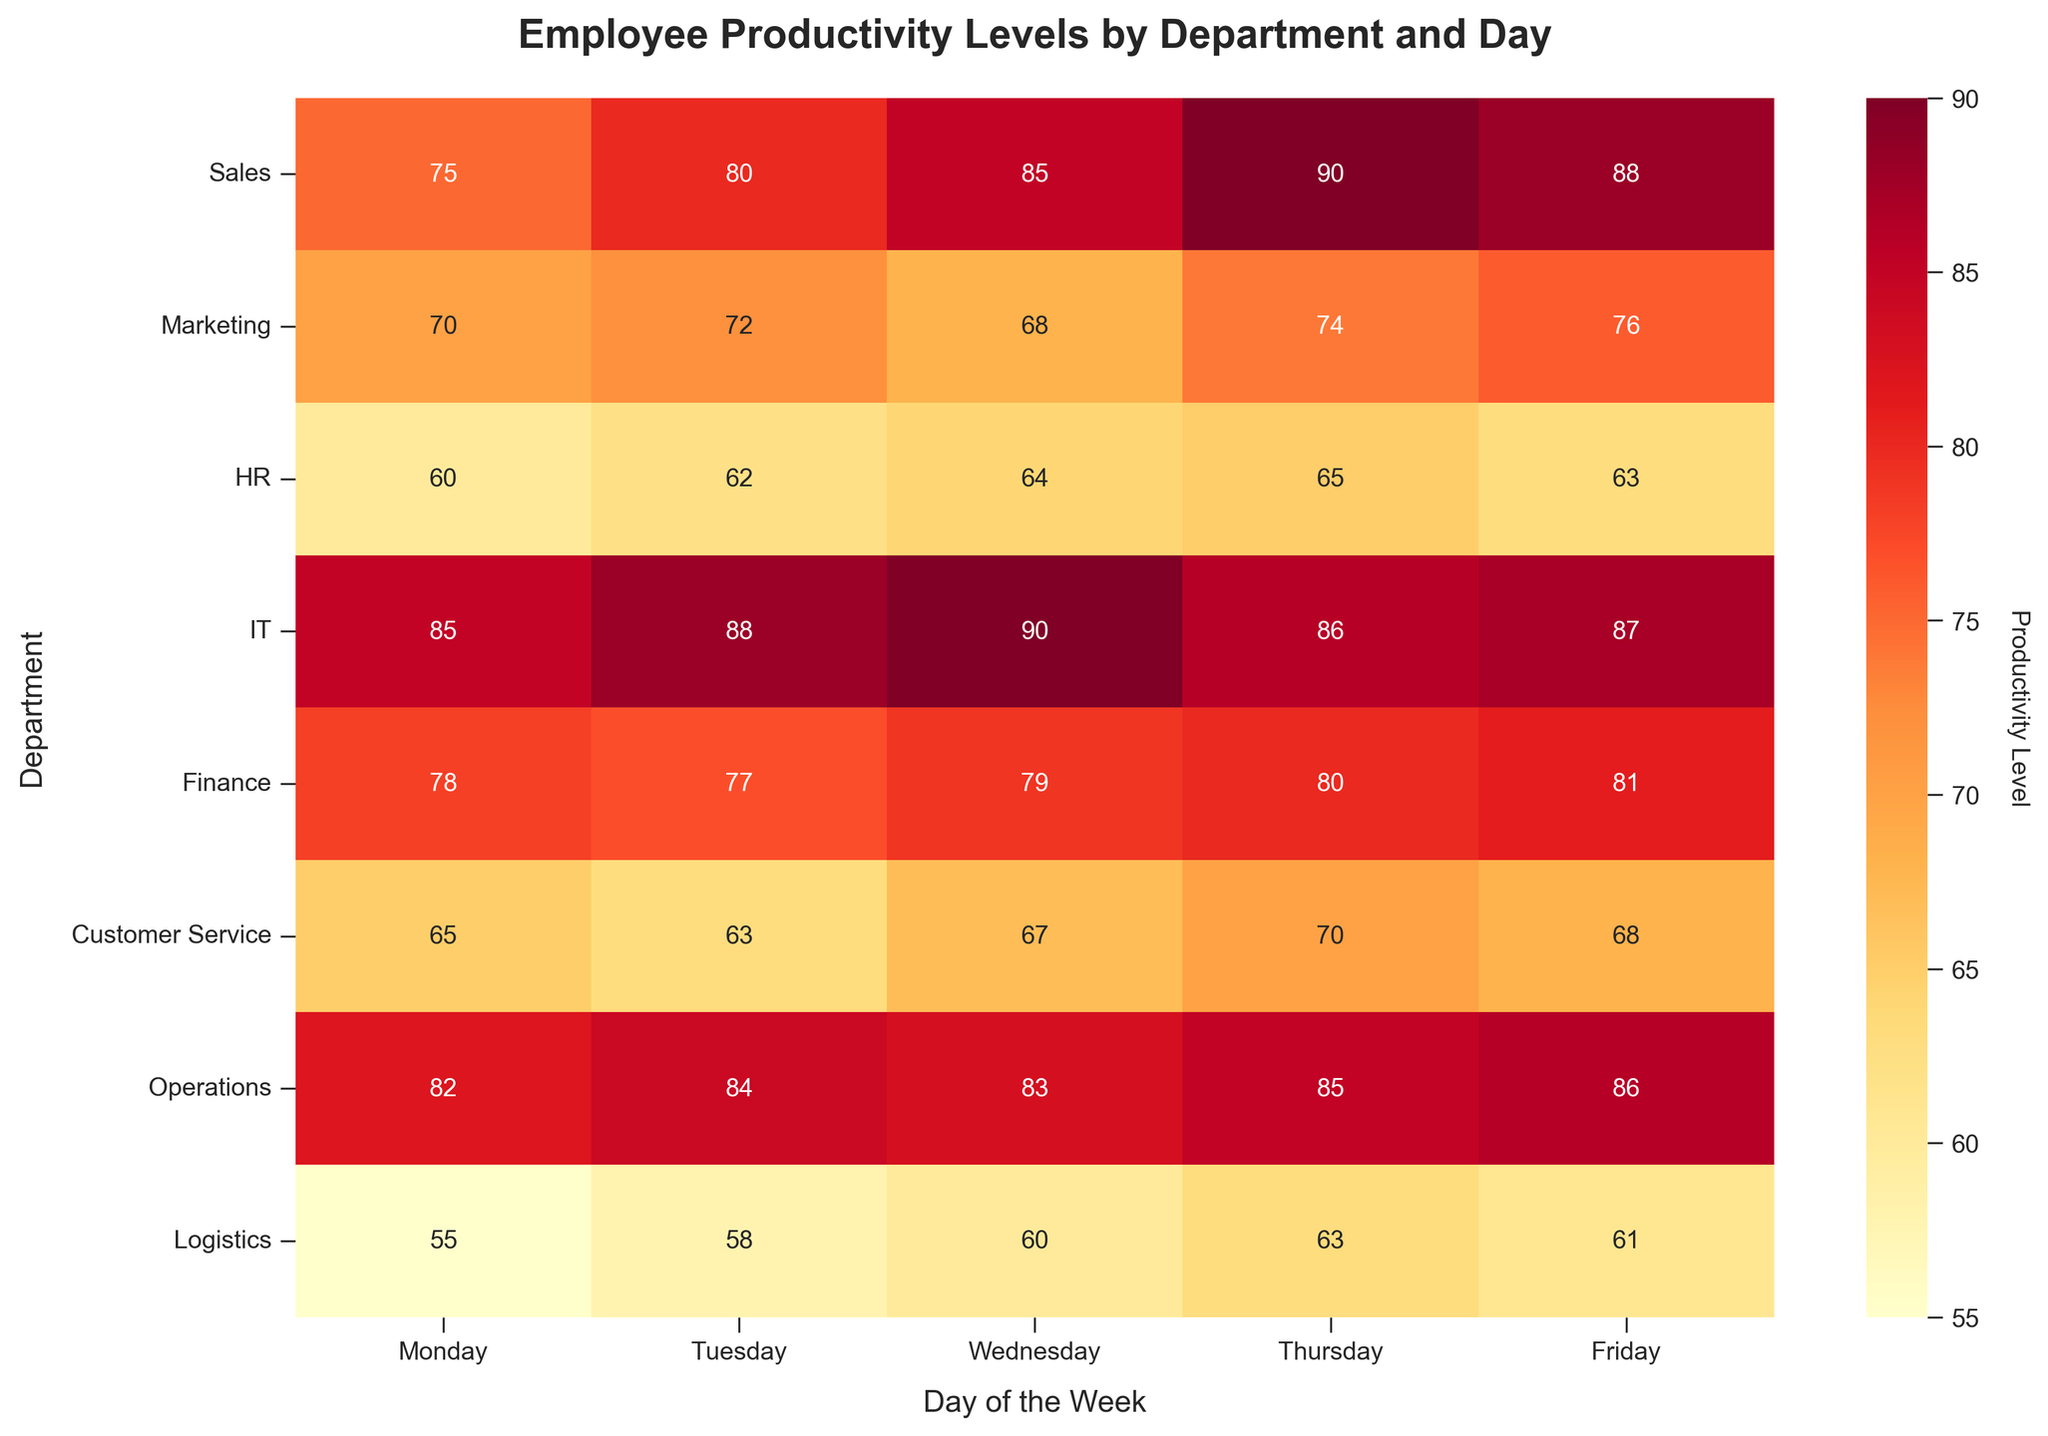What is the title of the heatmap? The heatmap's title is usually displayed at the top of the figure. For this heatmap, it is shown for better context and understanding of the data.
Answer: Employee Productivity Levels by Department and Day Which department has the highest productivity level on Friday? To find the highest productivity level on Friday, look at the Friday column and see which department has the highest value.
Answer: IT What is the average productivity level for the Sales department over the week? Add the productivity levels for Sales from Monday to Friday: 75, 80, 85, 90, 88. Sum: 75 + 80 + 85 + 90 + 88 = 418. Then divide by the number of days (5). Average: 418 / 5 = 83.6
Answer: 83.6 Which day shows the highest overall productivity levels across all departments? Sum the productivity levels for each day across all departments and compare the sums. The day with the highest sum has the highest overall productivity.
Answer: Thursday How does the productivity of Marketing compare between Monday and Wednesday? Compare the values in the Marketing row for Monday and Wednesday. Monday: 70, Wednesday: 68.
Answer: Monday is higher Which department shows the most variability in productivity across the week? Calculate the range (difference between max and min values) for each department. The department with the highest range shows the most variability.
Answer: Logistics On which day does the HR department have the highest productivity? Review the HR row to find the highest value and note the corresponding day.
Answer: Thursday Is there any day where Customer Service’s productivity is exactly 70? Check the Customer Service row to see if any cell has the value 70.
Answer: Thursday What is the average productivity level on Tuesdays across all departments? Sum the productivity levels for Tuesday across all departments: 80, 72, 62, 88, 77, 63, 84, 58. Sum: 584. Then divide by the number of departments (8). Average: 584 / 8 = 73
Answer: 73 Which two departments have the closest productivity levels on Wednesday? Compare the values in the Wednesday column for all departments and find the pair with the smallest difference.
Answer: HR & Logistics 